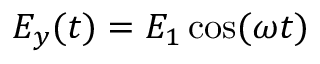<formula> <loc_0><loc_0><loc_500><loc_500>E _ { y } ( t ) = { E _ { 1 } } \cos ( \omega t )</formula> 